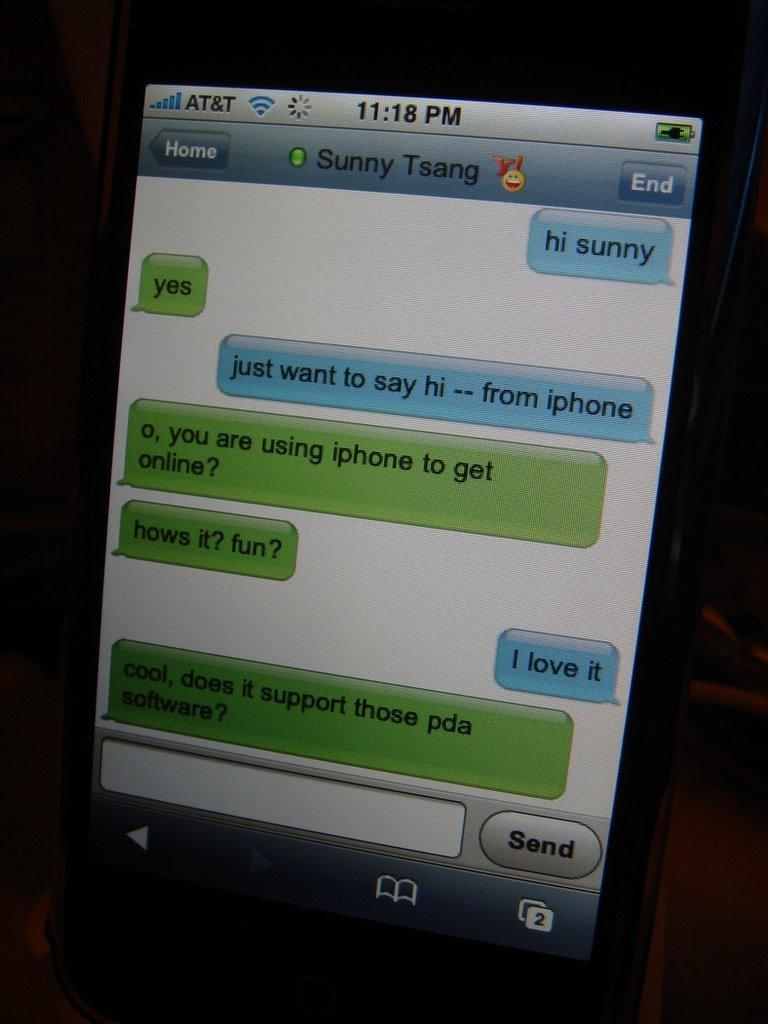<image>
Offer a succinct explanation of the picture presented. An iPhone text conversation has the name Sunny Tsang at the top. 